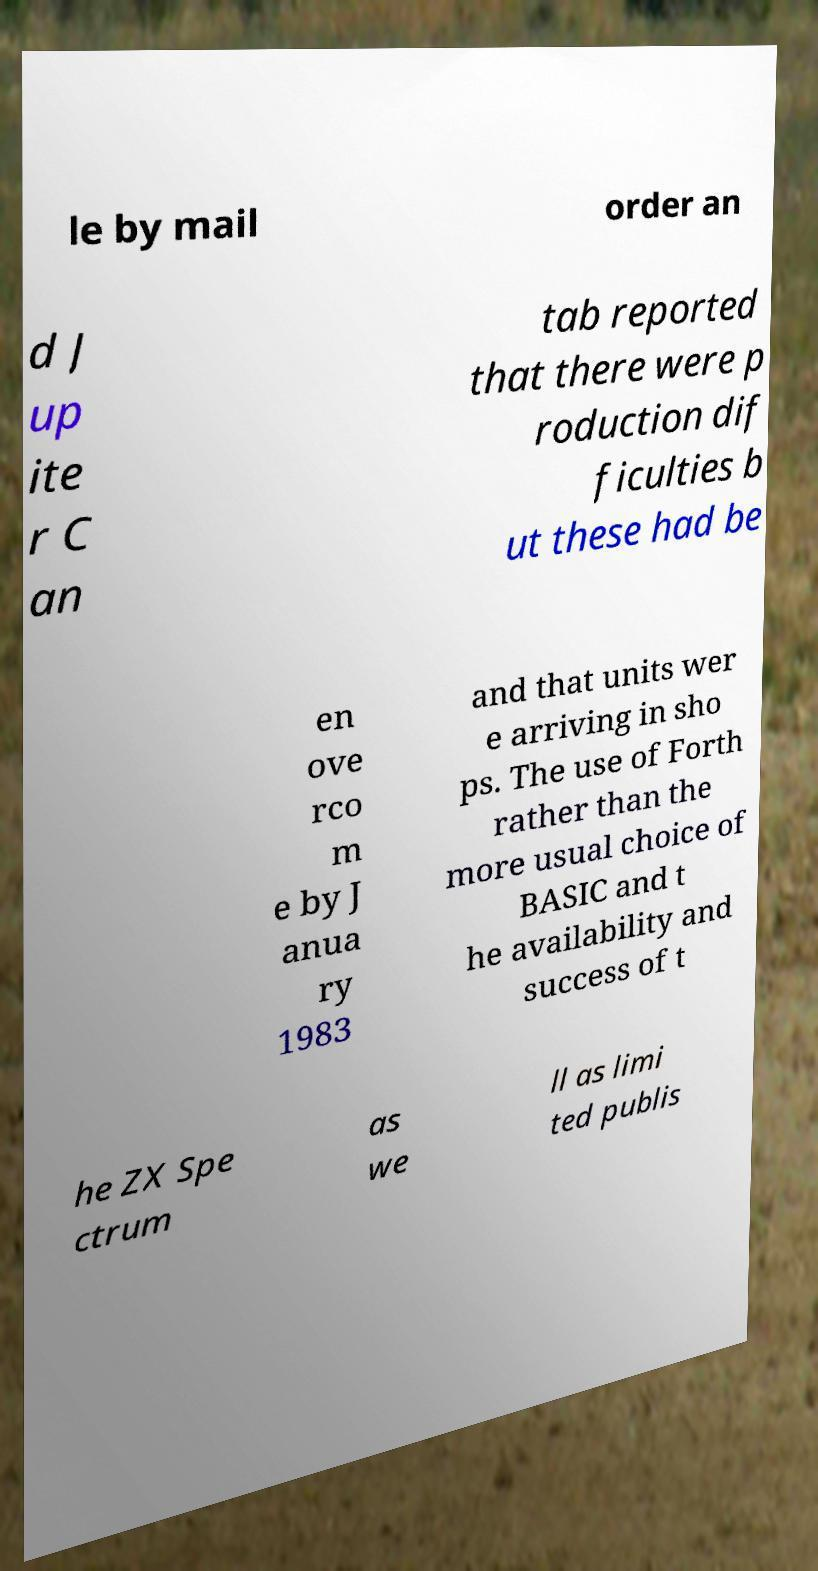I need the written content from this picture converted into text. Can you do that? le by mail order an d J up ite r C an tab reported that there were p roduction dif ficulties b ut these had be en ove rco m e by J anua ry 1983 and that units wer e arriving in sho ps. The use of Forth rather than the more usual choice of BASIC and t he availability and success of t he ZX Spe ctrum as we ll as limi ted publis 